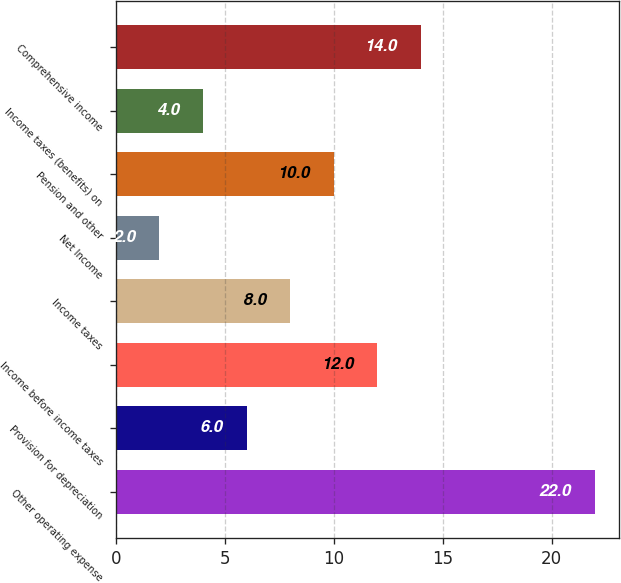<chart> <loc_0><loc_0><loc_500><loc_500><bar_chart><fcel>Other operating expense<fcel>Provision for depreciation<fcel>Income before income taxes<fcel>Income taxes<fcel>Net Income<fcel>Pension and other<fcel>Income taxes (benefits) on<fcel>Comprehensive income<nl><fcel>22<fcel>6<fcel>12<fcel>8<fcel>2<fcel>10<fcel>4<fcel>14<nl></chart> 